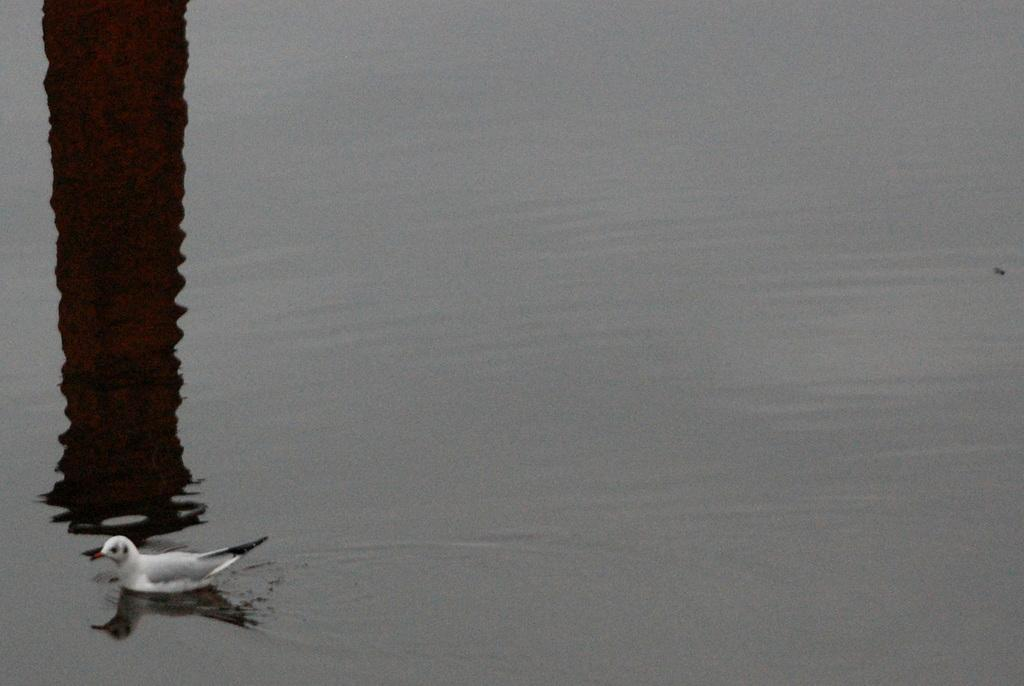What type of animal is in the image? There is a bird in the image. Where is the bird located in the image? The bird is on the water. What else can be seen in the image besides the bird? There is a shadow visible in the image. How many women are visible in the image? There are no women present in the image. What type of need is the bird using to catch fish in the image? The bird does not have a need, and there is no indication that it is trying to catch fish in the image. 